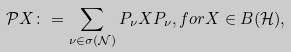Convert formula to latex. <formula><loc_0><loc_0><loc_500><loc_500>\mathcal { P } X \colon = \sum _ { \nu \in \sigma ( \mathcal { N } ) } P _ { \nu } X P _ { \nu } , f o r X \in B ( \mathcal { H } ) ,</formula> 